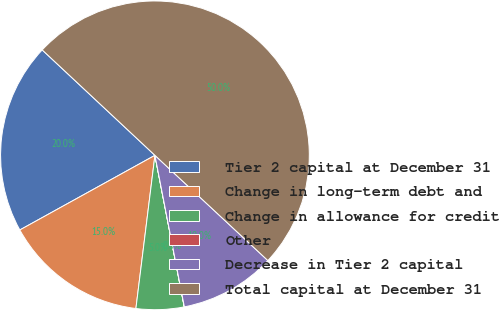Convert chart to OTSL. <chart><loc_0><loc_0><loc_500><loc_500><pie_chart><fcel>Tier 2 capital at December 31<fcel>Change in long-term debt and<fcel>Change in allowance for credit<fcel>Other<fcel>Decrease in Tier 2 capital<fcel>Total capital at December 31<nl><fcel>20.0%<fcel>15.0%<fcel>5.01%<fcel>0.01%<fcel>10.01%<fcel>49.97%<nl></chart> 